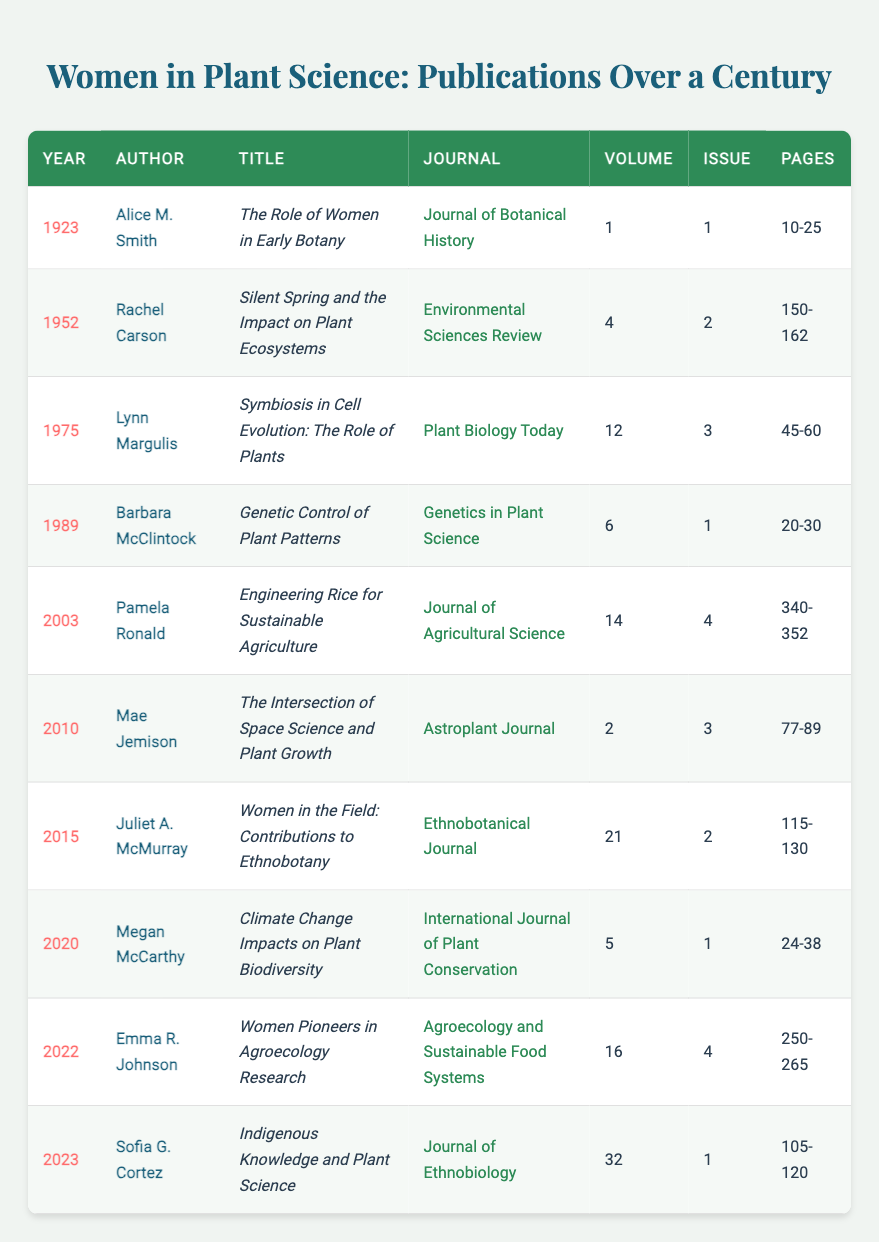What year was the publication "Silent Spring and the Impact on Plant Ecosystems" released? The title "Silent Spring and the Impact on Plant Ecosystems" corresponds to the author Rachel Carson, and a quick look at the row where her name appears shows that it was published in 1952.
Answer: 1952 Who authored the article "Women in the Field: Contributions to Ethnobotany"? The title "Women in the Field: Contributions to Ethnobotany" is listed in the row with Juliet A. McMurray, indicating she is the author.
Answer: Juliet A. McMurray In what journal was the article "Indigenous Knowledge and Plant Science" published? The title "Indigenous Knowledge and Plant Science" corresponds to the entry for Sofia G. Cortez, and the journal name is found in the column adjacent to her name, which is listed as the Journal of Ethnobiology.
Answer: Journal of Ethnobiology How many publications were authored by women in the year 2020? To determine the number of publications for 2020, I look for entries with the year 2020. There is one entry authored by Megan McCarthy, thus there is one publication for that year.
Answer: 1 Was Barbara McClintock's publication titled "Genetic Control of Plant Patterns" about plant genetics? The title "Genetic Control of Plant Patterns" clearly indicates a focus on genetics related to plants, confirming that the publication is indeed about plant genetics.
Answer: Yes Which author has the most recent publication and what is the title? The most recent publication is from the year 2023. By checking the last row of the table, it shows that Sofia G. Cortez authored the article titled "Indigenous Knowledge and Plant Science."
Answer: Sofia G. Cortez, "Indigenous Knowledge and Plant Science" What is the average volume number of publications from the 1980s (1980-1989)? I find the publications within that range, which include those from 1989 (volume 6). There are no entries from 1980 to 1988, so we only have one to average, which gives us an average volume of 6 based on that single entry.
Answer: 6 How many publications focus on sustainable practices? To answer this question, I scan the publication titles for keywords related to sustainability or sustainable practices. The articles by Pamela Ronald and Emma R. Johnson mention sustainable agriculture and agroecology respectively, totaling to 2 publications in this focus area.
Answer: 2 What is the earliest publication listed in the table? The first row indicates that the earliest year for publication is 1923, showing that Alice M. Smith is the author for that year.
Answer: 1923 